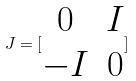<formula> <loc_0><loc_0><loc_500><loc_500>J = [ \begin{matrix} 0 & I \\ - I & 0 \end{matrix} ]</formula> 